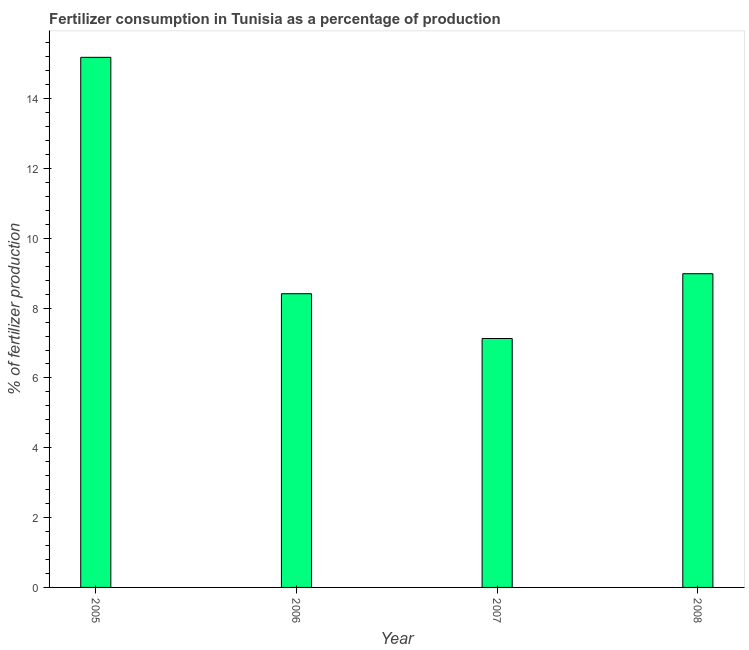Does the graph contain grids?
Your answer should be very brief. No. What is the title of the graph?
Your answer should be compact. Fertilizer consumption in Tunisia as a percentage of production. What is the label or title of the Y-axis?
Provide a succinct answer. % of fertilizer production. What is the amount of fertilizer consumption in 2008?
Offer a very short reply. 8.99. Across all years, what is the maximum amount of fertilizer consumption?
Make the answer very short. 15.18. Across all years, what is the minimum amount of fertilizer consumption?
Give a very brief answer. 7.13. In which year was the amount of fertilizer consumption maximum?
Make the answer very short. 2005. What is the sum of the amount of fertilizer consumption?
Your answer should be compact. 39.71. What is the difference between the amount of fertilizer consumption in 2005 and 2006?
Provide a short and direct response. 6.77. What is the average amount of fertilizer consumption per year?
Give a very brief answer. 9.93. What is the median amount of fertilizer consumption?
Ensure brevity in your answer.  8.7. What is the ratio of the amount of fertilizer consumption in 2007 to that in 2008?
Offer a very short reply. 0.79. Is the amount of fertilizer consumption in 2006 less than that in 2007?
Your answer should be very brief. No. What is the difference between the highest and the second highest amount of fertilizer consumption?
Offer a terse response. 6.2. What is the difference between the highest and the lowest amount of fertilizer consumption?
Make the answer very short. 8.05. In how many years, is the amount of fertilizer consumption greater than the average amount of fertilizer consumption taken over all years?
Your answer should be very brief. 1. Are all the bars in the graph horizontal?
Ensure brevity in your answer.  No. How many years are there in the graph?
Your answer should be very brief. 4. What is the difference between two consecutive major ticks on the Y-axis?
Keep it short and to the point. 2. Are the values on the major ticks of Y-axis written in scientific E-notation?
Provide a short and direct response. No. What is the % of fertilizer production in 2005?
Provide a succinct answer. 15.18. What is the % of fertilizer production in 2006?
Your answer should be very brief. 8.41. What is the % of fertilizer production in 2007?
Offer a very short reply. 7.13. What is the % of fertilizer production of 2008?
Ensure brevity in your answer.  8.99. What is the difference between the % of fertilizer production in 2005 and 2006?
Ensure brevity in your answer.  6.77. What is the difference between the % of fertilizer production in 2005 and 2007?
Your answer should be very brief. 8.05. What is the difference between the % of fertilizer production in 2005 and 2008?
Ensure brevity in your answer.  6.2. What is the difference between the % of fertilizer production in 2006 and 2007?
Ensure brevity in your answer.  1.28. What is the difference between the % of fertilizer production in 2006 and 2008?
Offer a terse response. -0.57. What is the difference between the % of fertilizer production in 2007 and 2008?
Give a very brief answer. -1.86. What is the ratio of the % of fertilizer production in 2005 to that in 2006?
Provide a succinct answer. 1.8. What is the ratio of the % of fertilizer production in 2005 to that in 2007?
Make the answer very short. 2.13. What is the ratio of the % of fertilizer production in 2005 to that in 2008?
Provide a short and direct response. 1.69. What is the ratio of the % of fertilizer production in 2006 to that in 2007?
Keep it short and to the point. 1.18. What is the ratio of the % of fertilizer production in 2006 to that in 2008?
Provide a short and direct response. 0.94. What is the ratio of the % of fertilizer production in 2007 to that in 2008?
Keep it short and to the point. 0.79. 